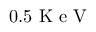<formula> <loc_0><loc_0><loc_500><loc_500>0 . 5 K e V</formula> 